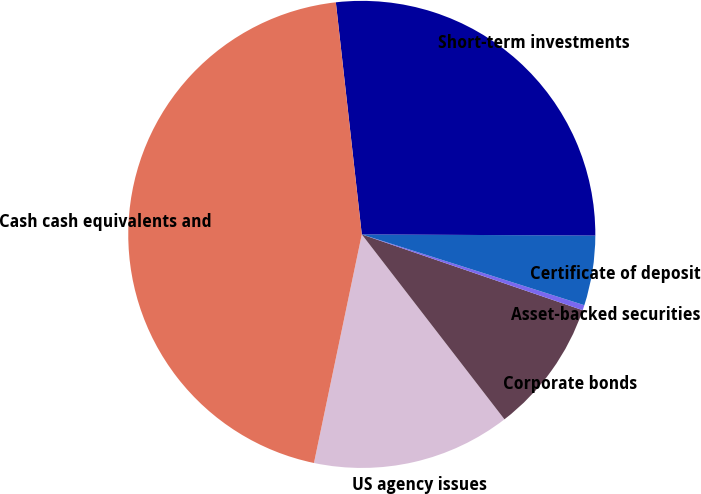<chart> <loc_0><loc_0><loc_500><loc_500><pie_chart><fcel>US agency issues<fcel>Corporate bonds<fcel>Asset-backed securities<fcel>Certificate of deposit<fcel>Short-term investments<fcel>Cash cash equivalents and<nl><fcel>13.74%<fcel>9.28%<fcel>0.36%<fcel>4.82%<fcel>26.85%<fcel>44.94%<nl></chart> 